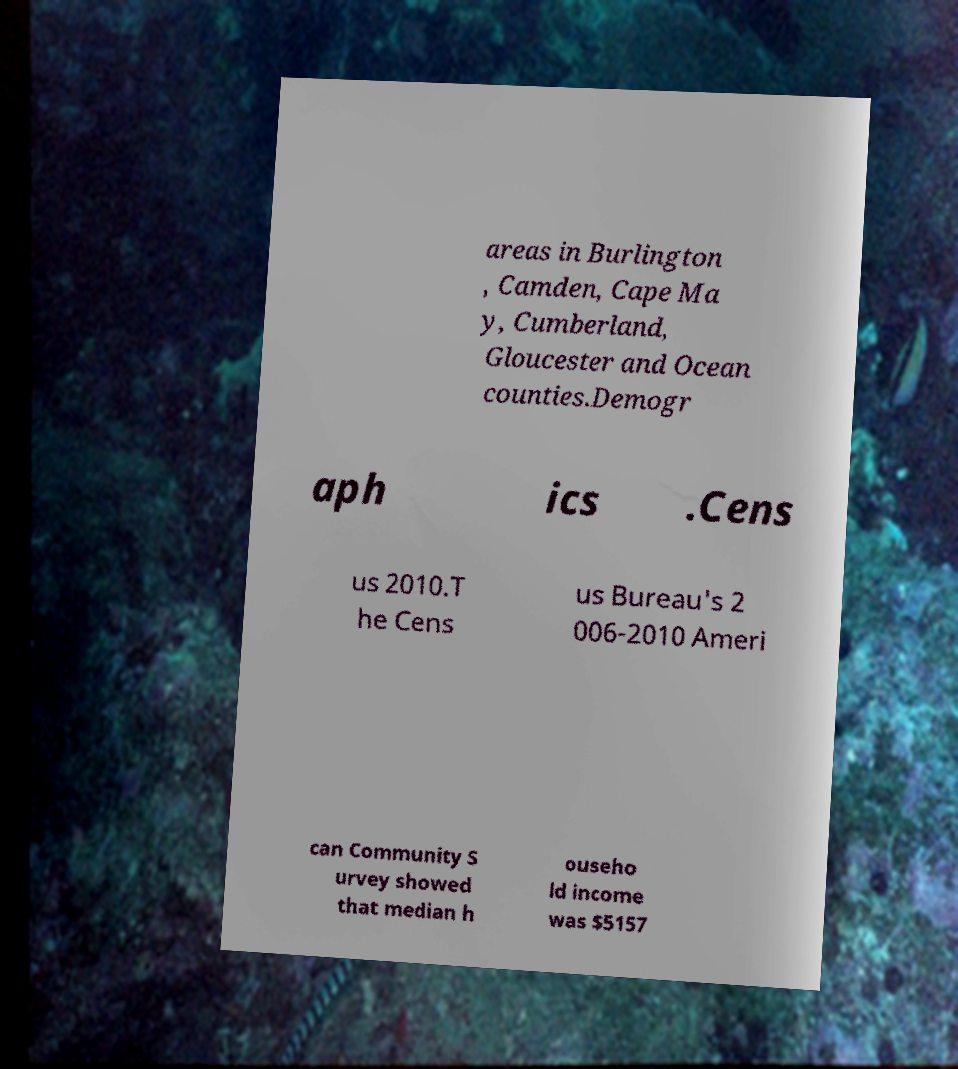I need the written content from this picture converted into text. Can you do that? areas in Burlington , Camden, Cape Ma y, Cumberland, Gloucester and Ocean counties.Demogr aph ics .Cens us 2010.T he Cens us Bureau's 2 006-2010 Ameri can Community S urvey showed that median h ouseho ld income was $5157 